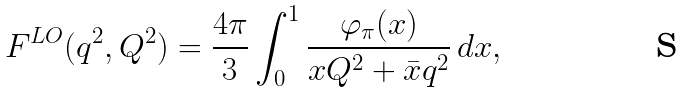Convert formula to latex. <formula><loc_0><loc_0><loc_500><loc_500>F ^ { L O } ( q ^ { 2 } , Q ^ { 2 } ) = \frac { 4 \pi } { 3 } \int _ { 0 } ^ { 1 } \frac { \varphi _ { \pi } ( x ) } { x Q ^ { 2 } + \bar { x } q ^ { 2 } } \, d x ,</formula> 